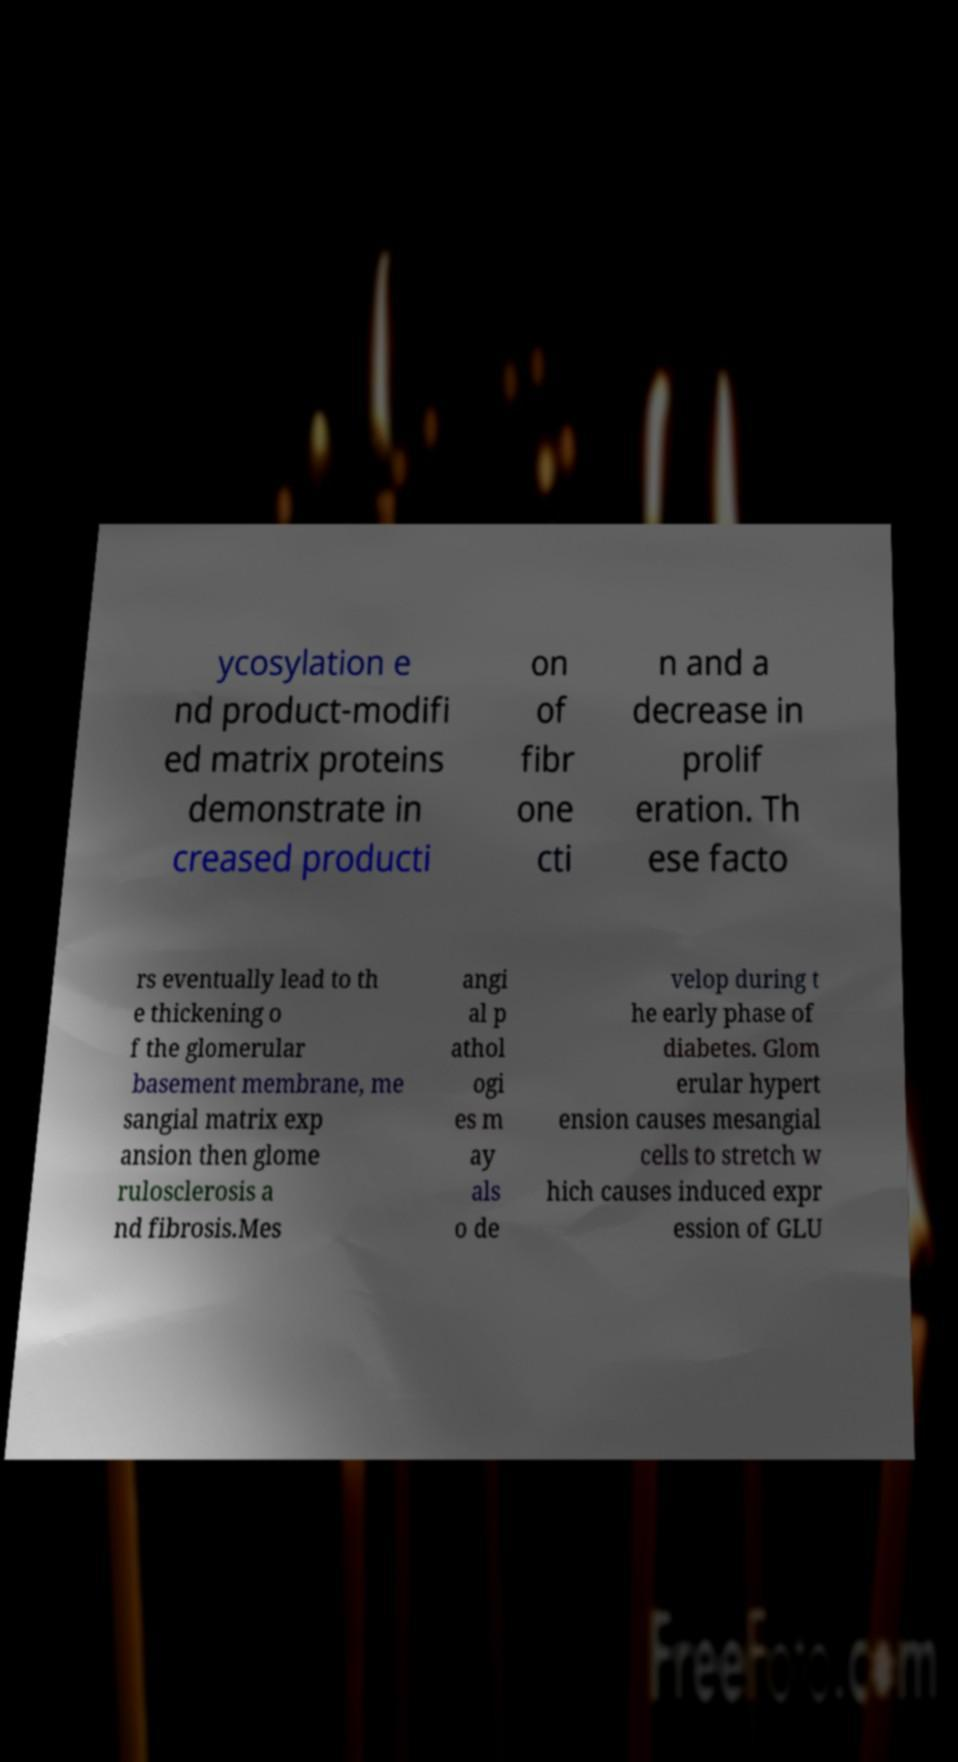Please read and relay the text visible in this image. What does it say? ycosylation e nd product-modifi ed matrix proteins demonstrate in creased producti on of fibr one cti n and a decrease in prolif eration. Th ese facto rs eventually lead to th e thickening o f the glomerular basement membrane, me sangial matrix exp ansion then glome rulosclerosis a nd fibrosis.Mes angi al p athol ogi es m ay als o de velop during t he early phase of diabetes. Glom erular hypert ension causes mesangial cells to stretch w hich causes induced expr ession of GLU 